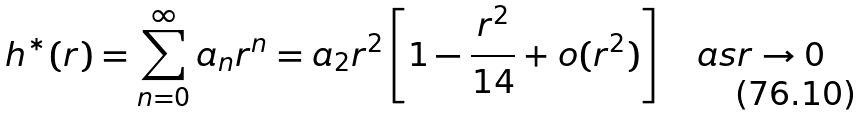<formula> <loc_0><loc_0><loc_500><loc_500>h ^ { * } ( r ) = \sum _ { n = 0 } ^ { \infty } a _ { n } r ^ { n } = a _ { 2 } r ^ { 2 } \left [ 1 - \frac { r ^ { 2 } } { 1 4 } + o ( r ^ { 2 } ) \right ] \quad a s r \to 0</formula> 